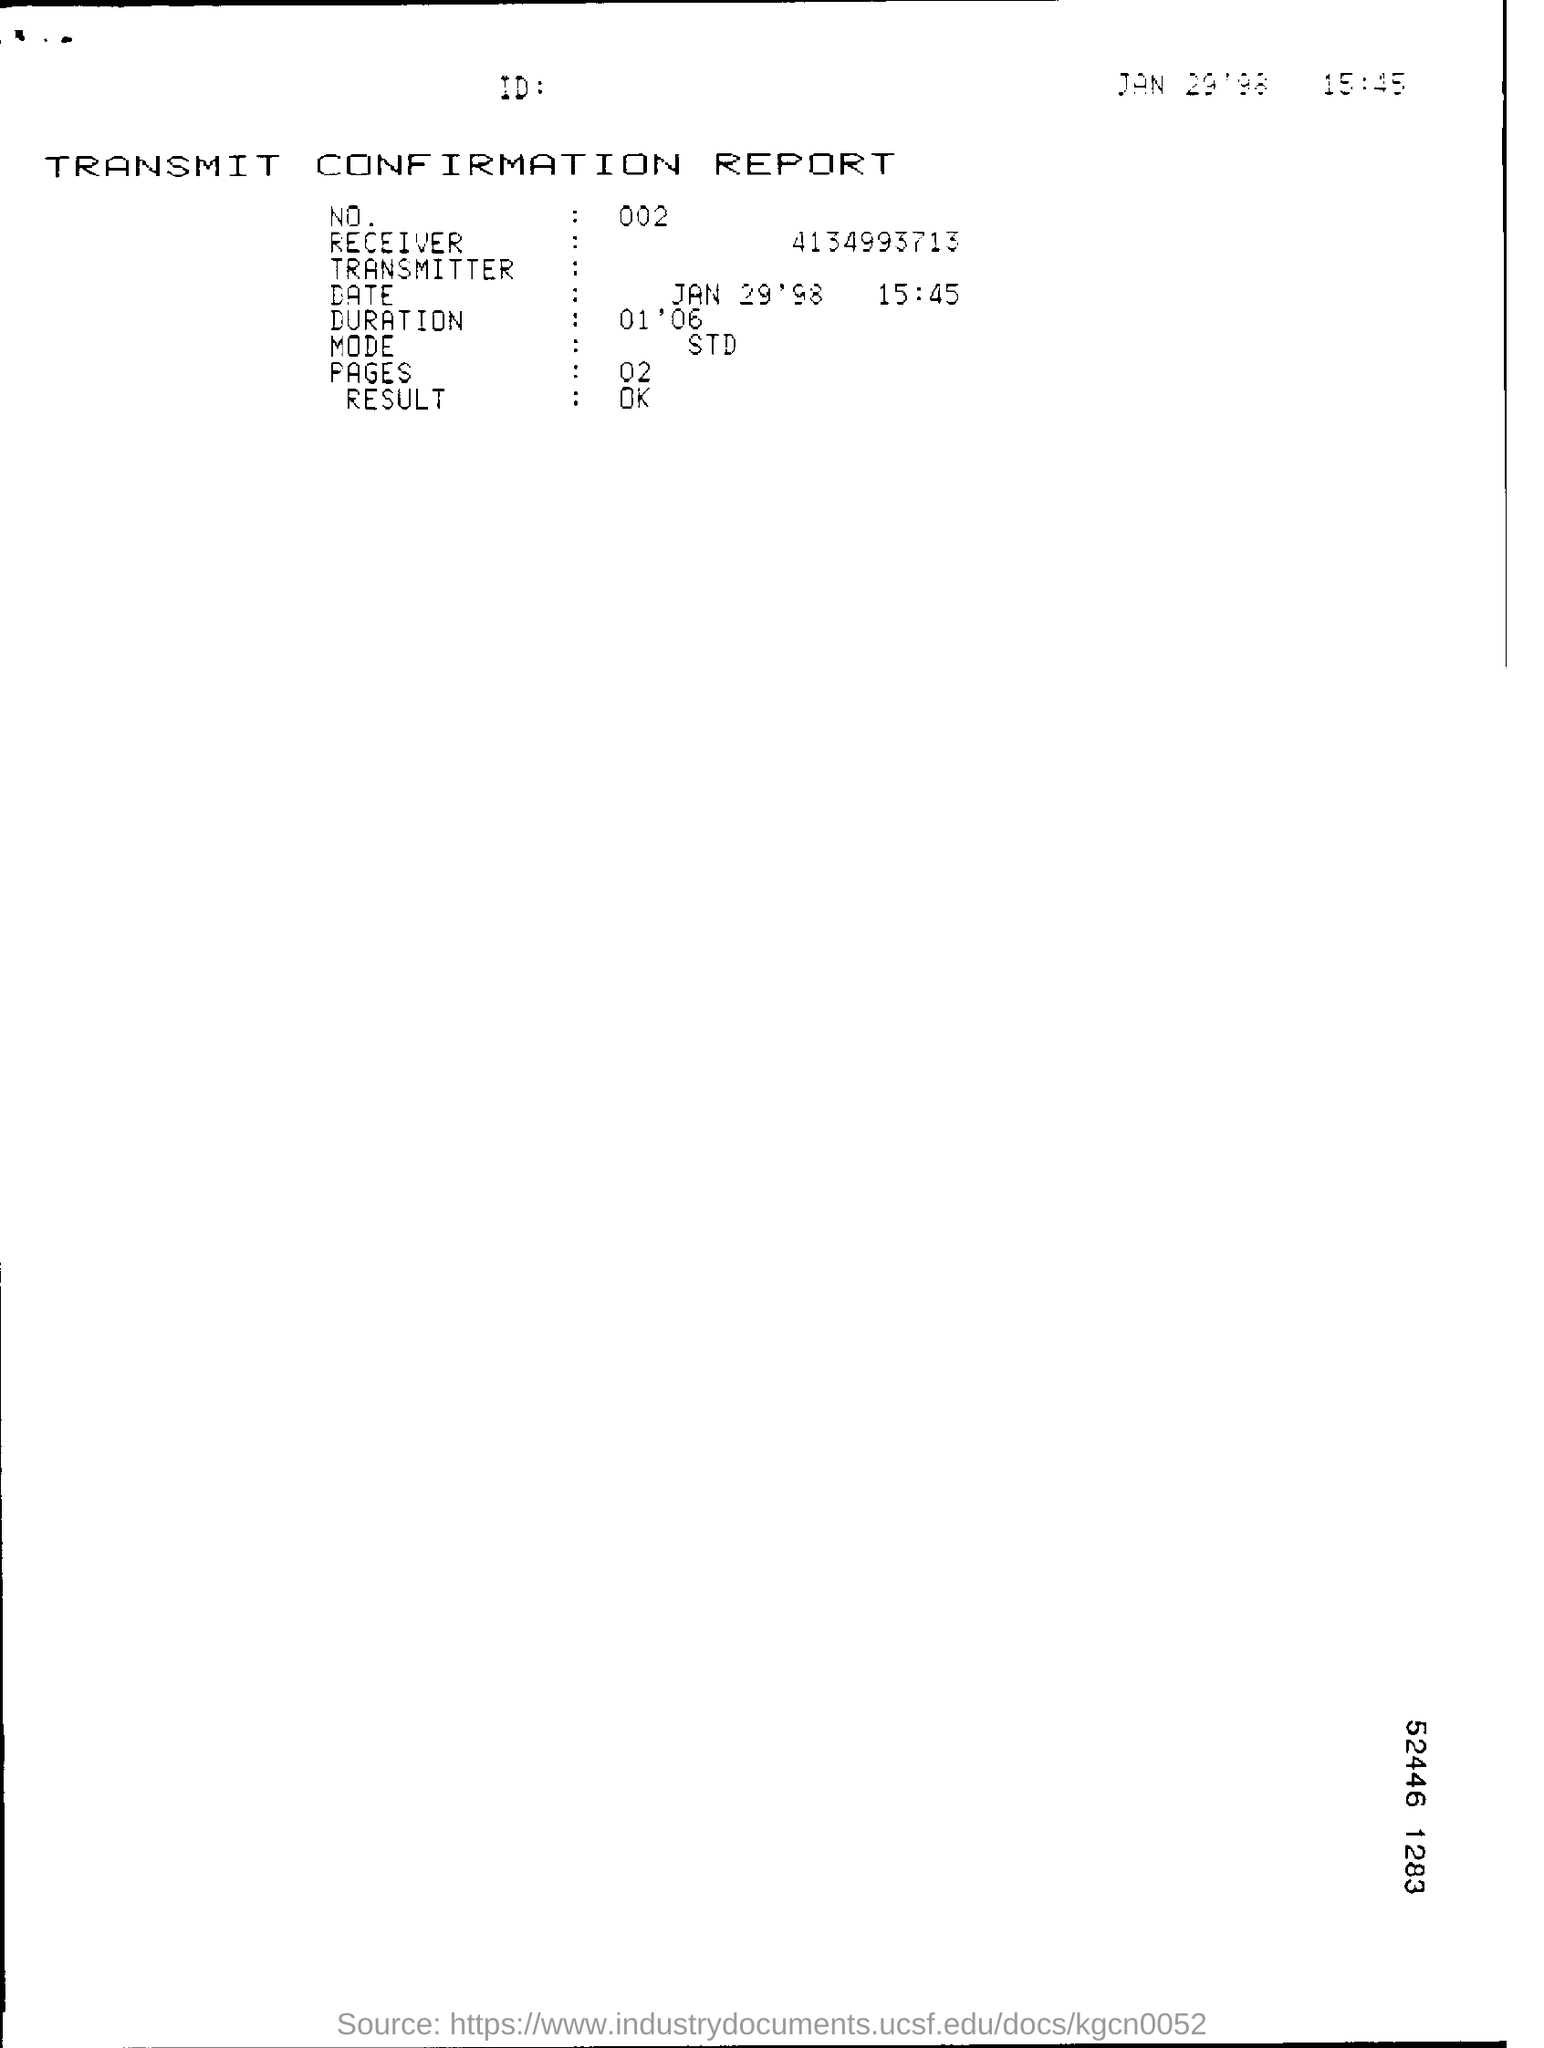Draw attention to some important aspects in this diagram. The mode of transmission for STDs has been identified as sexual contact. 